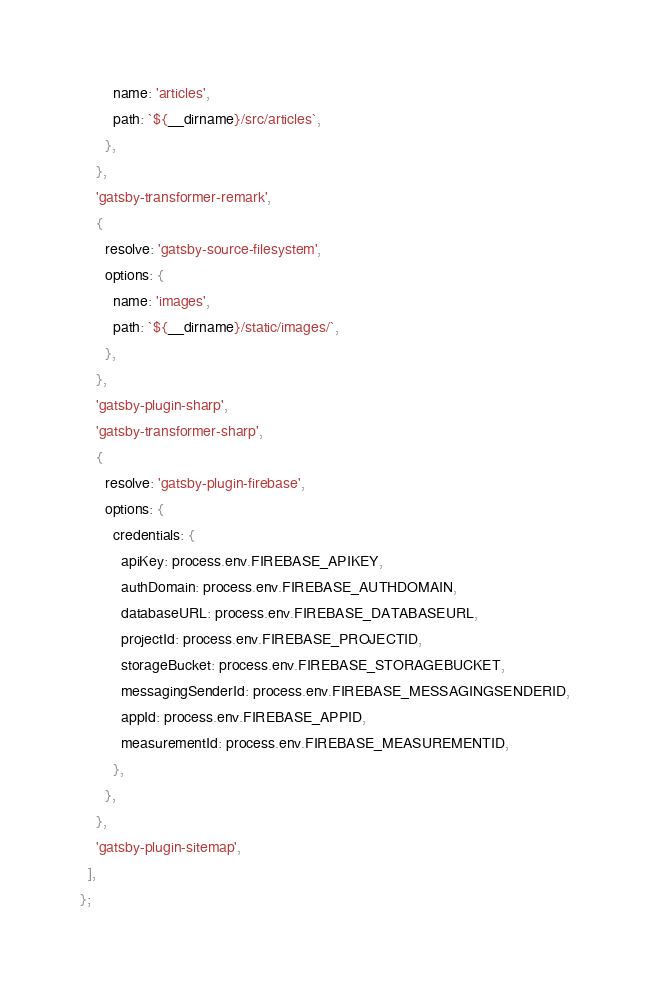<code> <loc_0><loc_0><loc_500><loc_500><_JavaScript_>        name: 'articles',
        path: `${__dirname}/src/articles`,
      },
    },
    'gatsby-transformer-remark',
    {
      resolve: 'gatsby-source-filesystem',
      options: {
        name: 'images',
        path: `${__dirname}/static/images/`,
      },
    },
    'gatsby-plugin-sharp',
    'gatsby-transformer-sharp',
    {
      resolve: 'gatsby-plugin-firebase',
      options: {
        credentials: {
          apiKey: process.env.FIREBASE_APIKEY,
          authDomain: process.env.FIREBASE_AUTHDOMAIN,
          databaseURL: process.env.FIREBASE_DATABASEURL,
          projectId: process.env.FIREBASE_PROJECTID,
          storageBucket: process.env.FIREBASE_STORAGEBUCKET,
          messagingSenderId: process.env.FIREBASE_MESSAGINGSENDERID,
          appId: process.env.FIREBASE_APPID,
          measurementId: process.env.FIREBASE_MEASUREMENTID,
        },
      },
    },
    'gatsby-plugin-sitemap',
  ],
};
</code> 